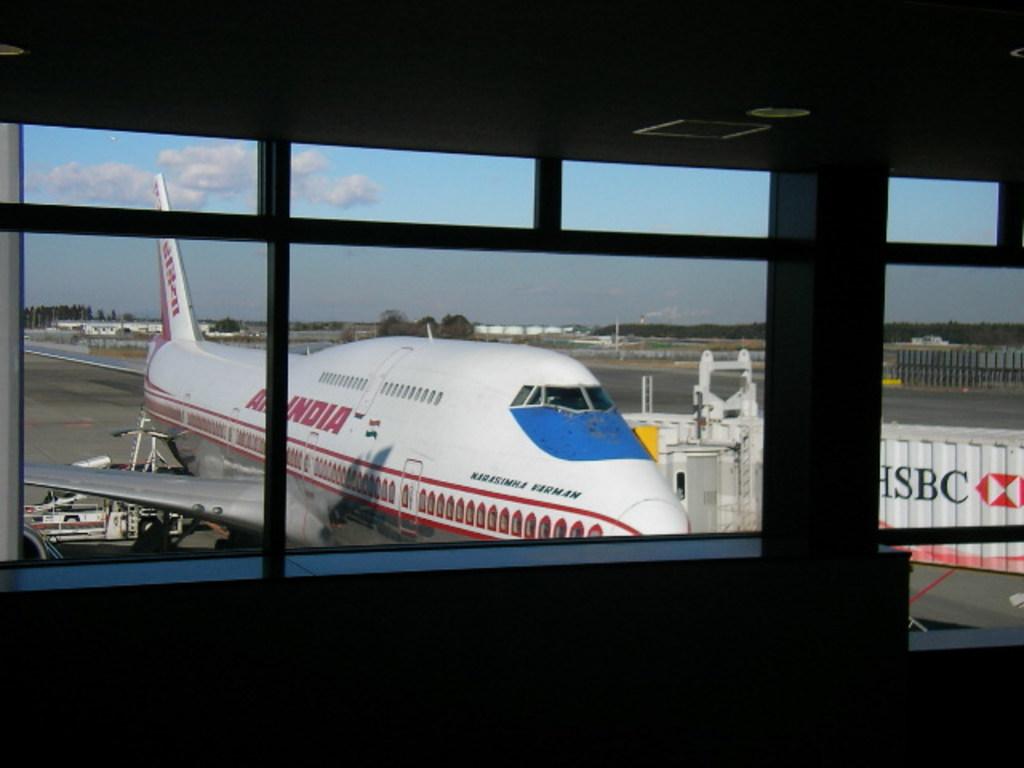Is this a library?
Offer a very short reply. Answering does not require reading text in the image. 